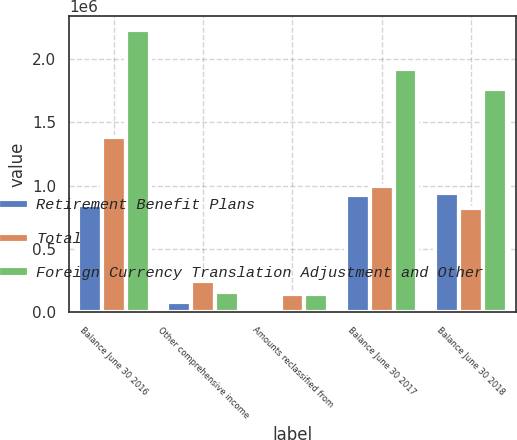Convert chart. <chart><loc_0><loc_0><loc_500><loc_500><stacked_bar_chart><ecel><fcel>Balance June 30 2016<fcel>Other comprehensive income<fcel>Amounts reclassified from<fcel>Balance June 30 2017<fcel>Balance June 30 2018<nl><fcel>Retirement Benefit Plans<fcel>844121<fcel>80189<fcel>1032<fcel>925342<fcel>943477<nl><fcel>Total<fcel>1.38364e+06<fcel>242414<fcel>142368<fcel>998862<fcel>819609<nl><fcel>Foreign Currency Translation Adjustment and Other<fcel>2.22776e+06<fcel>162225<fcel>141336<fcel>1.9242e+06<fcel>1.76309e+06<nl></chart> 